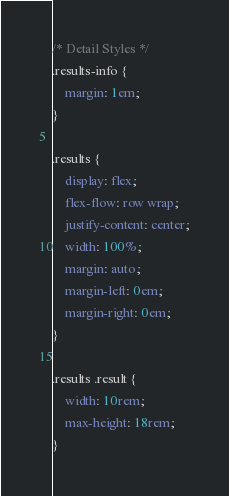Convert code to text. <code><loc_0><loc_0><loc_500><loc_500><_CSS_>/* Detail Styles */
.results-info {
    margin: 1em;
}

.results {
    display: flex;
    flex-flow: row wrap;
    justify-content: center;
    width: 100%;
    margin: auto;
    margin-left: 0em;
    margin-right: 0em;
}

.results .result {
    width: 10rem;
    max-height: 18rem;
}</code> 